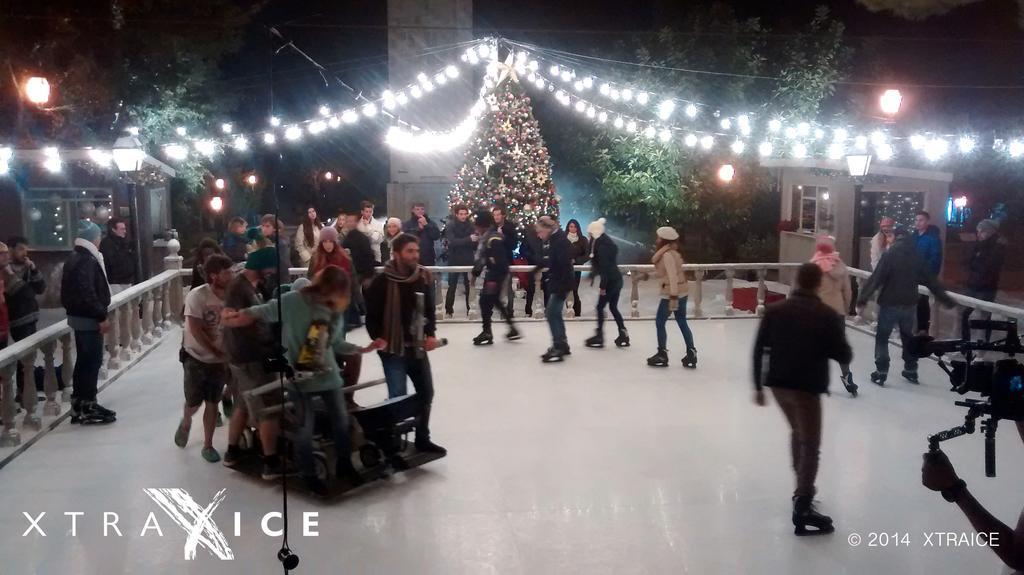Can you describe this image briefly? In this image I can see on the right side there is a person holding the camera, in the right hand side bottom there is the watermark. In the middle few people are doing the skating, on the left side there is the text. In the background there is a Christmas tree, there are trees and lights on either side of this image. 